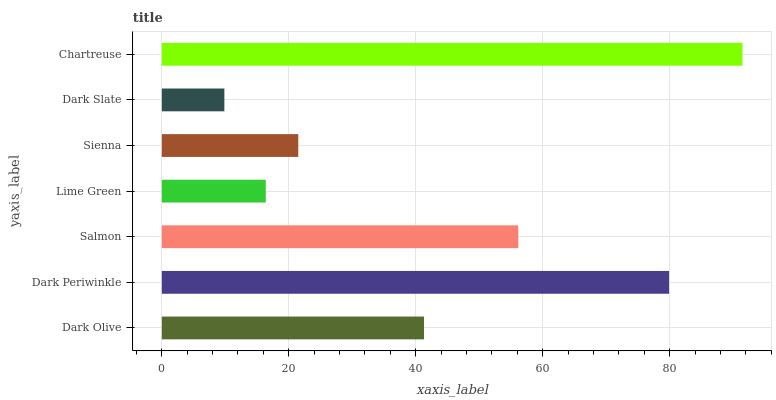Is Dark Slate the minimum?
Answer yes or no. Yes. Is Chartreuse the maximum?
Answer yes or no. Yes. Is Dark Periwinkle the minimum?
Answer yes or no. No. Is Dark Periwinkle the maximum?
Answer yes or no. No. Is Dark Periwinkle greater than Dark Olive?
Answer yes or no. Yes. Is Dark Olive less than Dark Periwinkle?
Answer yes or no. Yes. Is Dark Olive greater than Dark Periwinkle?
Answer yes or no. No. Is Dark Periwinkle less than Dark Olive?
Answer yes or no. No. Is Dark Olive the high median?
Answer yes or no. Yes. Is Dark Olive the low median?
Answer yes or no. Yes. Is Salmon the high median?
Answer yes or no. No. Is Salmon the low median?
Answer yes or no. No. 